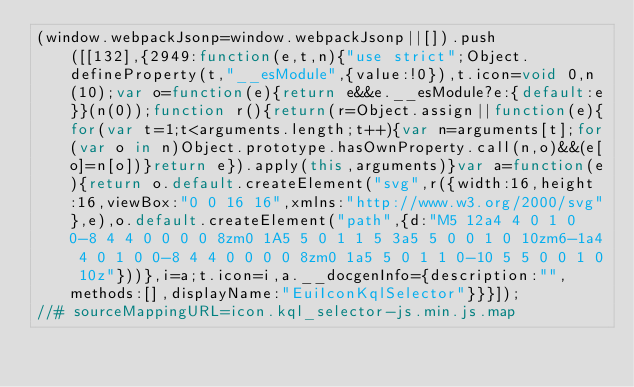Convert code to text. <code><loc_0><loc_0><loc_500><loc_500><_JavaScript_>(window.webpackJsonp=window.webpackJsonp||[]).push([[132],{2949:function(e,t,n){"use strict";Object.defineProperty(t,"__esModule",{value:!0}),t.icon=void 0,n(10);var o=function(e){return e&&e.__esModule?e:{default:e}}(n(0));function r(){return(r=Object.assign||function(e){for(var t=1;t<arguments.length;t++){var n=arguments[t];for(var o in n)Object.prototype.hasOwnProperty.call(n,o)&&(e[o]=n[o])}return e}).apply(this,arguments)}var a=function(e){return o.default.createElement("svg",r({width:16,height:16,viewBox:"0 0 16 16",xmlns:"http://www.w3.org/2000/svg"},e),o.default.createElement("path",{d:"M5 12a4 4 0 1 0 0-8 4 4 0 0 0 0 8zm0 1A5 5 0 1 1 5 3a5 5 0 0 1 0 10zm6-1a4 4 0 1 0 0-8 4 4 0 0 0 0 8zm0 1a5 5 0 1 1 0-10 5 5 0 0 1 0 10z"}))},i=a;t.icon=i,a.__docgenInfo={description:"",methods:[],displayName:"EuiIconKqlSelector"}}}]);
//# sourceMappingURL=icon.kql_selector-js.min.js.map</code> 